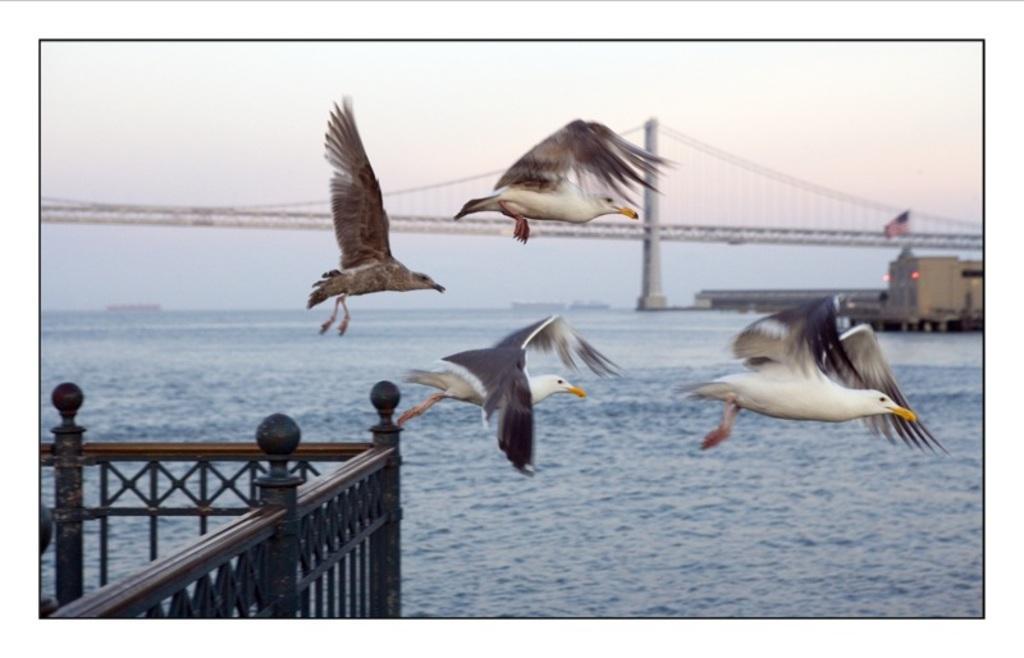In one or two sentences, can you explain what this image depicts? In the picture I can see white color birds are flying in the air. In the background I can see fence, water, the sky and some other things. 